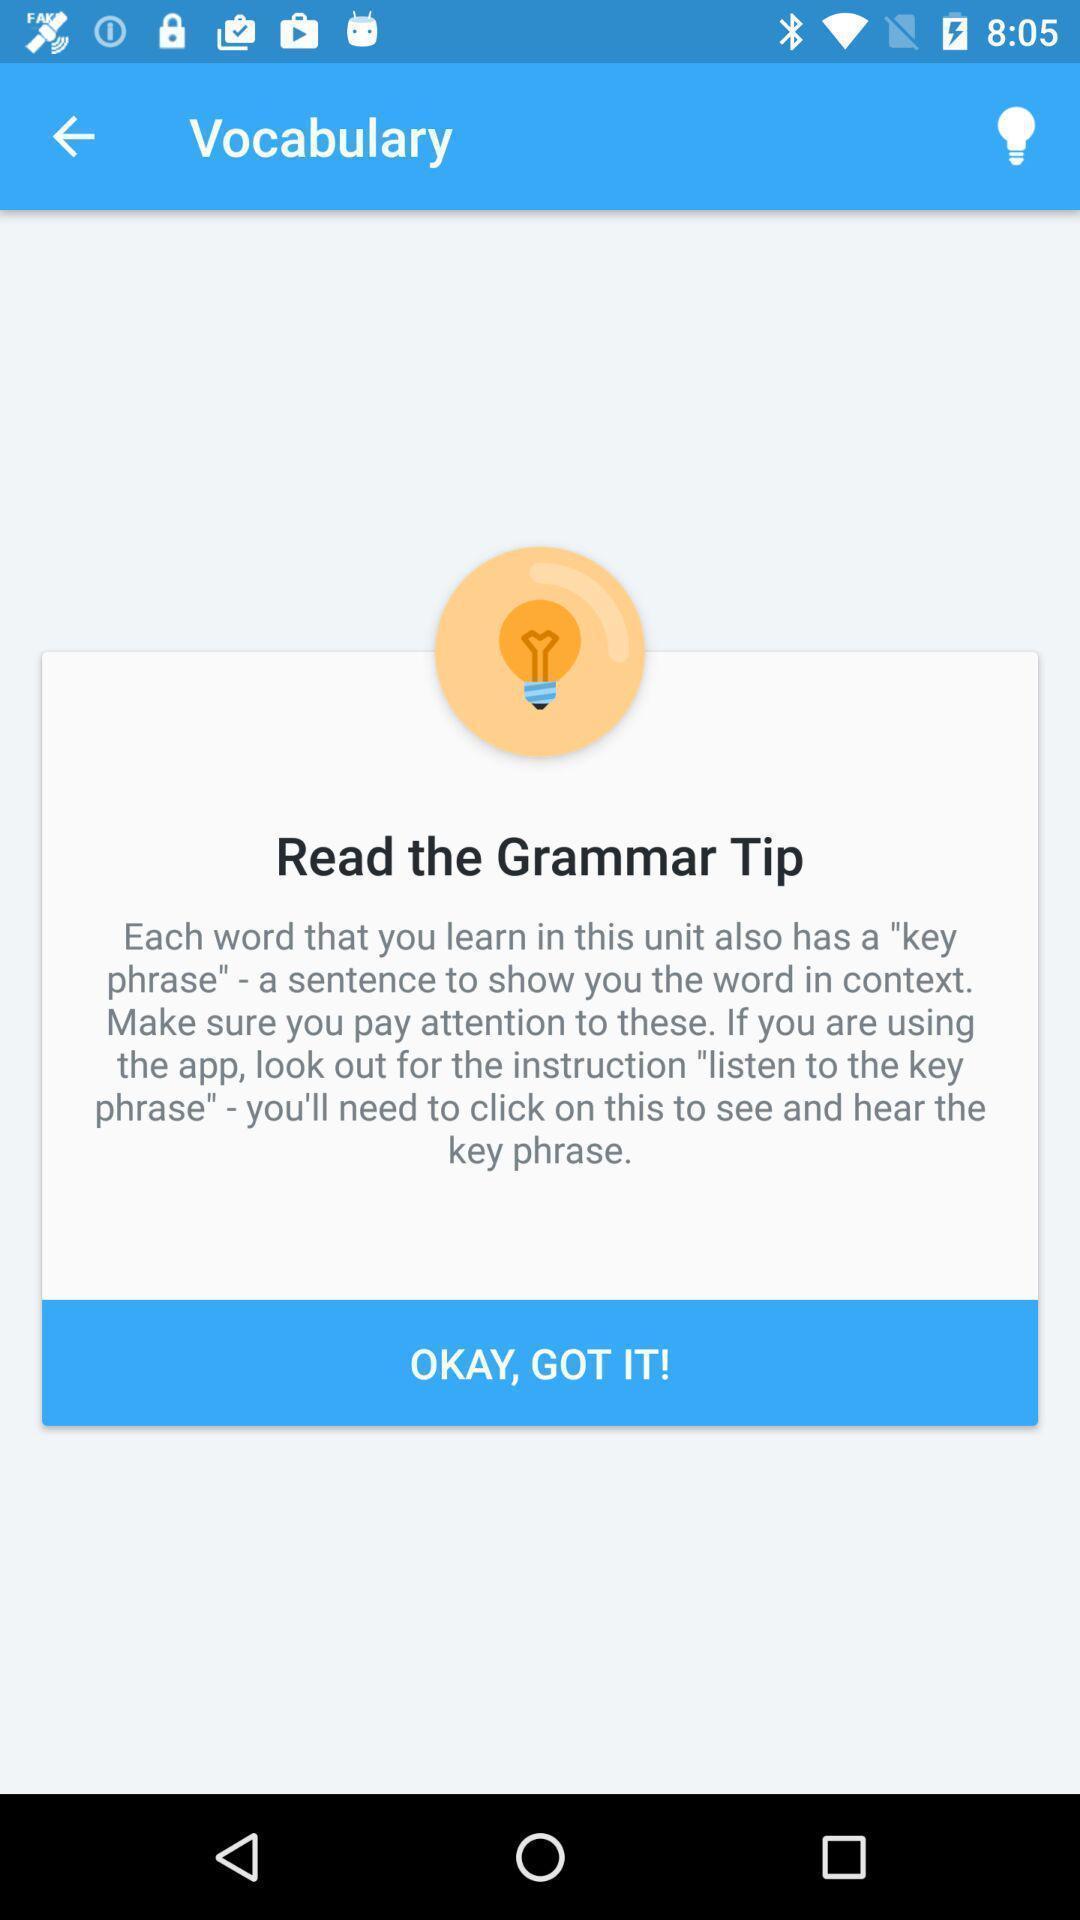Describe the visual elements of this screenshot. Pop up window displayings tips. 